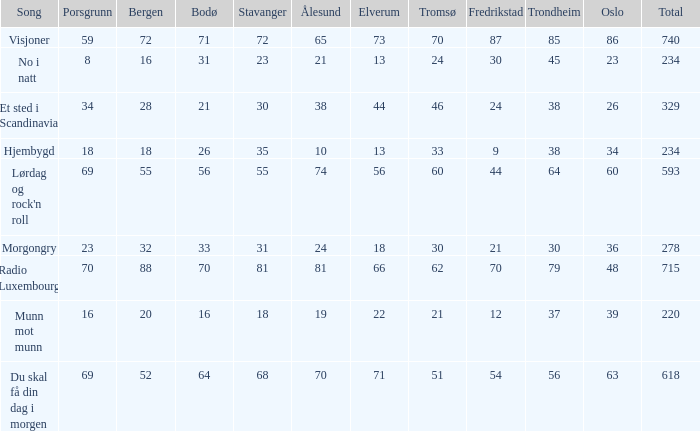When the total score is 740, what is tromso? 70.0. 